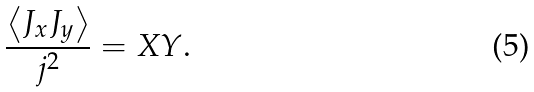<formula> <loc_0><loc_0><loc_500><loc_500>\frac { \left \langle J _ { x } J _ { y } \right \rangle } { j ^ { 2 } } = X Y \text {.}</formula> 